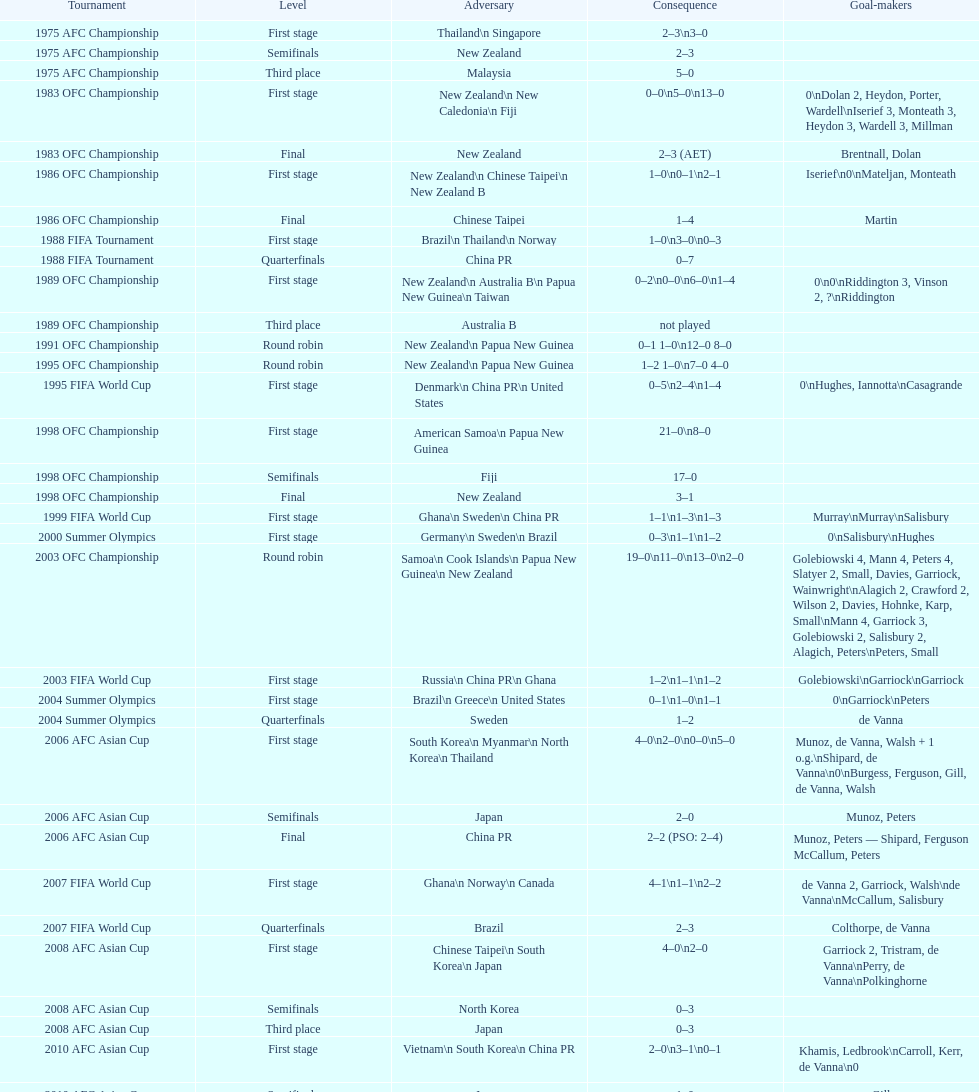How many players scored during the 1983 ofc championship competition? 9. Can you parse all the data within this table? {'header': ['Tournament', 'Level', 'Adversary', 'Consequence', 'Goal-makers'], 'rows': [['1975 AFC Championship', 'First stage', 'Thailand\\n\xa0Singapore', '2–3\\n3–0', ''], ['1975 AFC Championship', 'Semifinals', 'New Zealand', '2–3', ''], ['1975 AFC Championship', 'Third place', 'Malaysia', '5–0', ''], ['1983 OFC Championship', 'First stage', 'New Zealand\\n\xa0New Caledonia\\n\xa0Fiji', '0–0\\n5–0\\n13–0', '0\\nDolan 2, Heydon, Porter, Wardell\\nIserief 3, Monteath 3, Heydon 3, Wardell 3, Millman'], ['1983 OFC Championship', 'Final', 'New Zealand', '2–3 (AET)', 'Brentnall, Dolan'], ['1986 OFC Championship', 'First stage', 'New Zealand\\n\xa0Chinese Taipei\\n New Zealand B', '1–0\\n0–1\\n2–1', 'Iserief\\n0\\nMateljan, Monteath'], ['1986 OFC Championship', 'Final', 'Chinese Taipei', '1–4', 'Martin'], ['1988 FIFA Tournament', 'First stage', 'Brazil\\n\xa0Thailand\\n\xa0Norway', '1–0\\n3–0\\n0–3', ''], ['1988 FIFA Tournament', 'Quarterfinals', 'China PR', '0–7', ''], ['1989 OFC Championship', 'First stage', 'New Zealand\\n Australia B\\n\xa0Papua New Guinea\\n\xa0Taiwan', '0–2\\n0–0\\n6–0\\n1–4', '0\\n0\\nRiddington 3, Vinson 2,\xa0?\\nRiddington'], ['1989 OFC Championship', 'Third place', 'Australia B', 'not played', ''], ['1991 OFC Championship', 'Round robin', 'New Zealand\\n\xa0Papua New Guinea', '0–1 1–0\\n12–0 8–0', ''], ['1995 OFC Championship', 'Round robin', 'New Zealand\\n\xa0Papua New Guinea', '1–2 1–0\\n7–0 4–0', ''], ['1995 FIFA World Cup', 'First stage', 'Denmark\\n\xa0China PR\\n\xa0United States', '0–5\\n2–4\\n1–4', '0\\nHughes, Iannotta\\nCasagrande'], ['1998 OFC Championship', 'First stage', 'American Samoa\\n\xa0Papua New Guinea', '21–0\\n8–0', ''], ['1998 OFC Championship', 'Semifinals', 'Fiji', '17–0', ''], ['1998 OFC Championship', 'Final', 'New Zealand', '3–1', ''], ['1999 FIFA World Cup', 'First stage', 'Ghana\\n\xa0Sweden\\n\xa0China PR', '1–1\\n1–3\\n1–3', 'Murray\\nMurray\\nSalisbury'], ['2000 Summer Olympics', 'First stage', 'Germany\\n\xa0Sweden\\n\xa0Brazil', '0–3\\n1–1\\n1–2', '0\\nSalisbury\\nHughes'], ['2003 OFC Championship', 'Round robin', 'Samoa\\n\xa0Cook Islands\\n\xa0Papua New Guinea\\n\xa0New Zealand', '19–0\\n11–0\\n13–0\\n2–0', 'Golebiowski 4, Mann 4, Peters 4, Slatyer 2, Small, Davies, Garriock, Wainwright\\nAlagich 2, Crawford 2, Wilson 2, Davies, Hohnke, Karp, Small\\nMann 4, Garriock 3, Golebiowski 2, Salisbury 2, Alagich, Peters\\nPeters, Small'], ['2003 FIFA World Cup', 'First stage', 'Russia\\n\xa0China PR\\n\xa0Ghana', '1–2\\n1–1\\n1–2', 'Golebiowski\\nGarriock\\nGarriock'], ['2004 Summer Olympics', 'First stage', 'Brazil\\n\xa0Greece\\n\xa0United States', '0–1\\n1–0\\n1–1', '0\\nGarriock\\nPeters'], ['2004 Summer Olympics', 'Quarterfinals', 'Sweden', '1–2', 'de Vanna'], ['2006 AFC Asian Cup', 'First stage', 'South Korea\\n\xa0Myanmar\\n\xa0North Korea\\n\xa0Thailand', '4–0\\n2–0\\n0–0\\n5–0', 'Munoz, de Vanna, Walsh + 1 o.g.\\nShipard, de Vanna\\n0\\nBurgess, Ferguson, Gill, de Vanna, Walsh'], ['2006 AFC Asian Cup', 'Semifinals', 'Japan', '2–0', 'Munoz, Peters'], ['2006 AFC Asian Cup', 'Final', 'China PR', '2–2 (PSO: 2–4)', 'Munoz, Peters — Shipard, Ferguson McCallum, Peters'], ['2007 FIFA World Cup', 'First stage', 'Ghana\\n\xa0Norway\\n\xa0Canada', '4–1\\n1–1\\n2–2', 'de Vanna 2, Garriock, Walsh\\nde Vanna\\nMcCallum, Salisbury'], ['2007 FIFA World Cup', 'Quarterfinals', 'Brazil', '2–3', 'Colthorpe, de Vanna'], ['2008 AFC Asian Cup', 'First stage', 'Chinese Taipei\\n\xa0South Korea\\n\xa0Japan', '4–0\\n2–0', 'Garriock 2, Tristram, de Vanna\\nPerry, de Vanna\\nPolkinghorne'], ['2008 AFC Asian Cup', 'Semifinals', 'North Korea', '0–3', ''], ['2008 AFC Asian Cup', 'Third place', 'Japan', '0–3', ''], ['2010 AFC Asian Cup', 'First stage', 'Vietnam\\n\xa0South Korea\\n\xa0China PR', '2–0\\n3–1\\n0–1', 'Khamis, Ledbrook\\nCarroll, Kerr, de Vanna\\n0'], ['2010 AFC Asian Cup', 'Semifinals', 'Japan', '1–0', 'Gill'], ['2010 AFC Asian Cup', 'Final', 'North Korea', '1–1 (PSO: 5–4)', 'Kerr — PSO: Shipard, Ledbrook, Gill, Garriock, Simon'], ['2011 FIFA World Cup', 'First stage', 'Brazil\\n\xa0Equatorial Guinea\\n\xa0Norway', '0–1\\n3–2\\n2–1', '0\\nvan Egmond, Khamis, de Vanna\\nSimon 2'], ['2011 FIFA World Cup', 'Quarterfinals', 'Sweden', '1–3', 'Perry'], ['2012 Summer Olympics\\nAFC qualification', 'Final round', 'North Korea\\n\xa0Thailand\\n\xa0Japan\\n\xa0China PR\\n\xa0South Korea', '0–1\\n5–1\\n0–1\\n1–0\\n2–1', '0\\nHeyman 2, Butt, van Egmond, Simon\\n0\\nvan Egmond\\nButt, de Vanna'], ['2014 AFC Asian Cup', 'First stage', 'Japan\\n\xa0Jordan\\n\xa0Vietnam', 'TBD\\nTBD\\nTBD', '']]} 